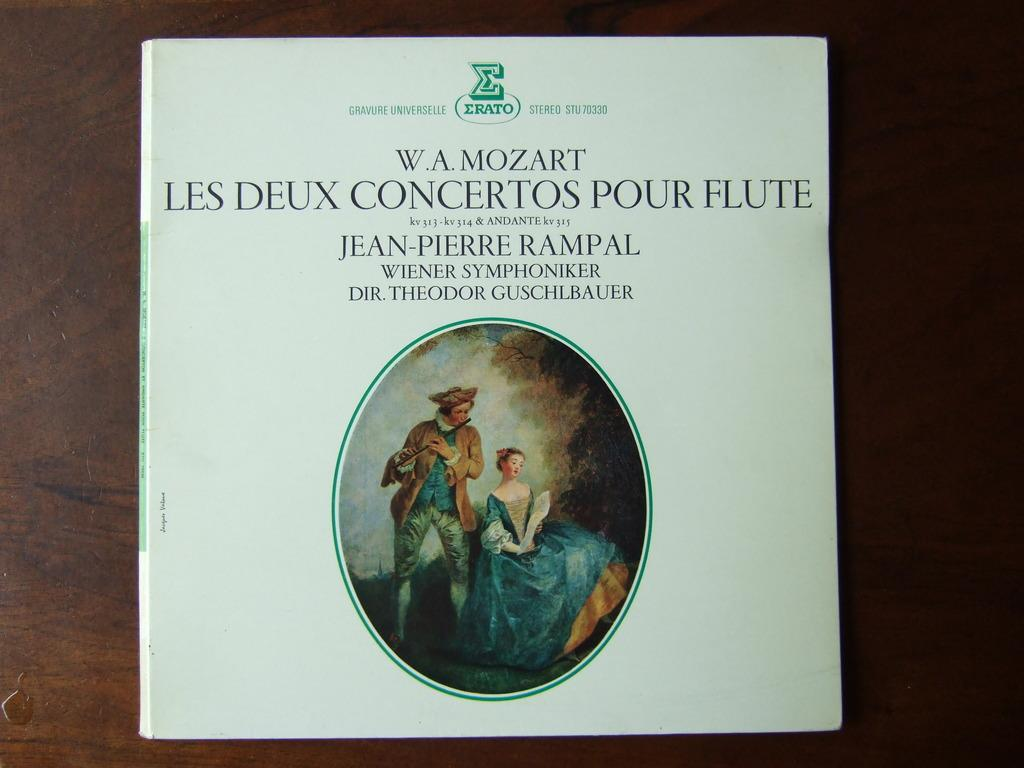Provide a one-sentence caption for the provided image. Book about W.A. Mozart Les Deux concertos pour flute. 